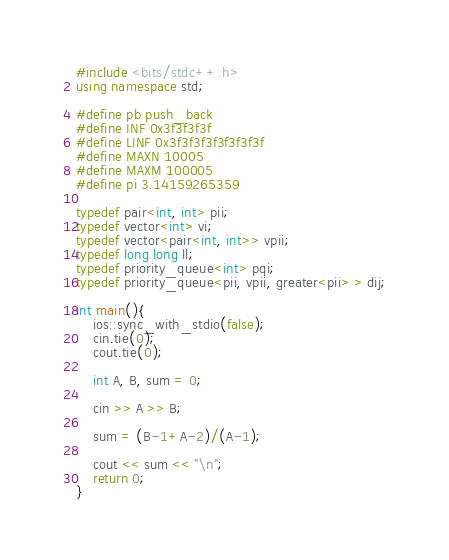Convert code to text. <code><loc_0><loc_0><loc_500><loc_500><_C++_>
#include <bits/stdc++.h>
using namespace std;

#define pb push_back
#define INF 0x3f3f3f3f
#define LINF 0x3f3f3f3f3f3f3f3f
#define MAXN 10005
#define MAXM 100005
#define pi 3.14159265359

typedef pair<int, int> pii;
typedef vector<int> vi;
typedef vector<pair<int, int>> vpii;
typedef long long ll;
typedef priority_queue<int> pqi;
typedef priority_queue<pii, vpii, greater<pii> > dij;

int main(){
	ios::sync_with_stdio(false);
	cin.tie(0);
	cout.tie(0);

	int A, B, sum = 0;

	cin >> A >> B;

	sum = (B-1+A-2)/(A-1);

	cout << sum << "\n";
	return 0;		
}</code> 